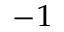<formula> <loc_0><loc_0><loc_500><loc_500>^ { - 1 }</formula> 